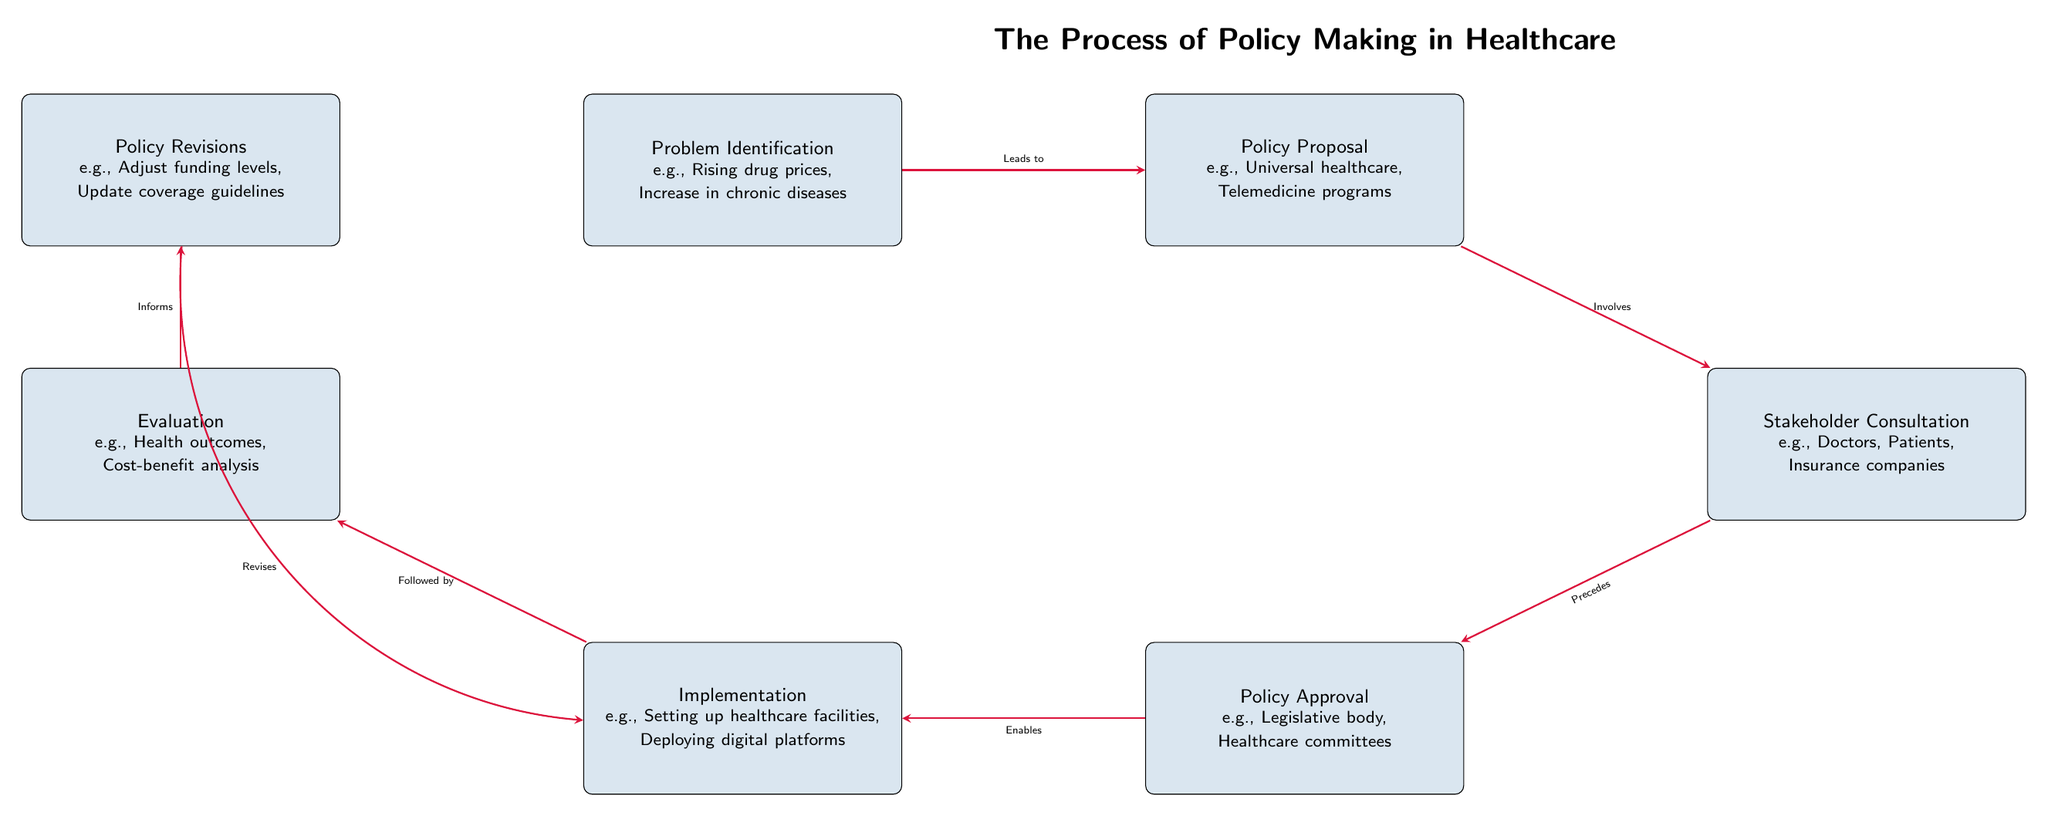What is the first step in the policy-making process? The first step in the diagram is "Problem Identification," which is located at the top left corner of the diagram.
Answer: Problem Identification How many main steps are shown in the policy-making process? Counting the boxes in the diagram reveals seven main steps: Problem Identification, Policy Proposal, Stakeholder Consultation, Policy Approval, Implementation, Evaluation, and Policy Revisions.
Answer: Seven What does stakeholder consultation involve? The diagram specifies "Doctors, Patients, Insurance companies" as examples of stakeholders involved in the "Stakeholder Consultation" step.
Answer: Doctors, Patients, Insurance companies What step directly follows implementation? Referring to the arrows in the diagram, "Evaluation" is the step that directly follows "Implementation."
Answer: Evaluation Which step informs the revisions in policy-making? The diagram indicates that "Evaluation" informs "Policy Revisions," meaning it provides necessary feedback for updating policies.
Answer: Evaluation How does a policy proposal lead to stakeholder consultation? According to the arrow connecting the two, "Policy Proposal" involves "Stakeholder Consultation," indicating that after a proposal is made, consultations are conducted.
Answer: Involves What two steps are connected by the arrow labeled "Enables"? The arrow labeled "Enables" connects "Policy Approval" to "Implementation," indicating that approval of policies allows their implementation.
Answer: Policy Approval, Implementation Which step is located above the implementation step? The diagram shows that "Evaluation" is situated directly above the "Implementation" step.
Answer: Evaluation What happens to the implementation after policy revisions? The diagram explains that "Policy Revisions" will revise the "Implementation" step, which suggests adjustments or updates are made to how policies are implemented.
Answer: Revises 